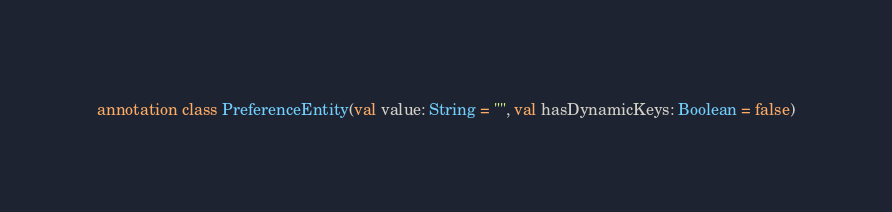Convert code to text. <code><loc_0><loc_0><loc_500><loc_500><_Kotlin_>

annotation class PreferenceEntity(val value: String = "", val hasDynamicKeys: Boolean = false)</code> 